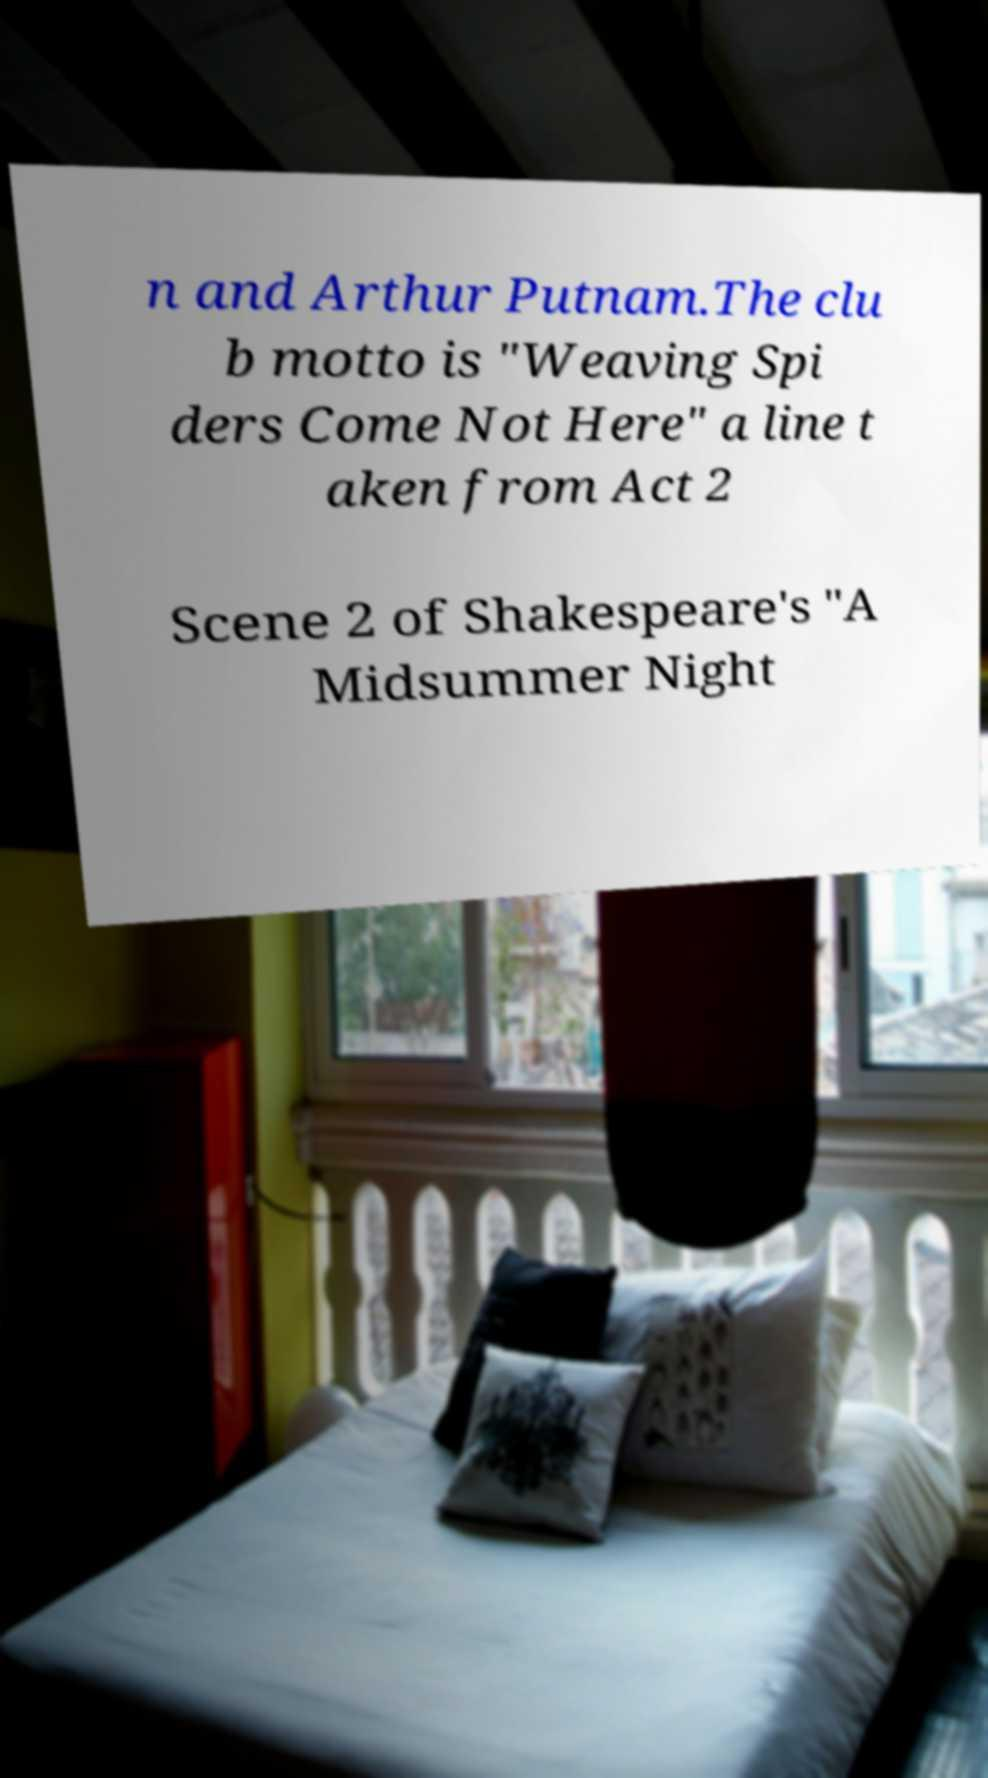Please identify and transcribe the text found in this image. n and Arthur Putnam.The clu b motto is "Weaving Spi ders Come Not Here" a line t aken from Act 2 Scene 2 of Shakespeare's "A Midsummer Night 